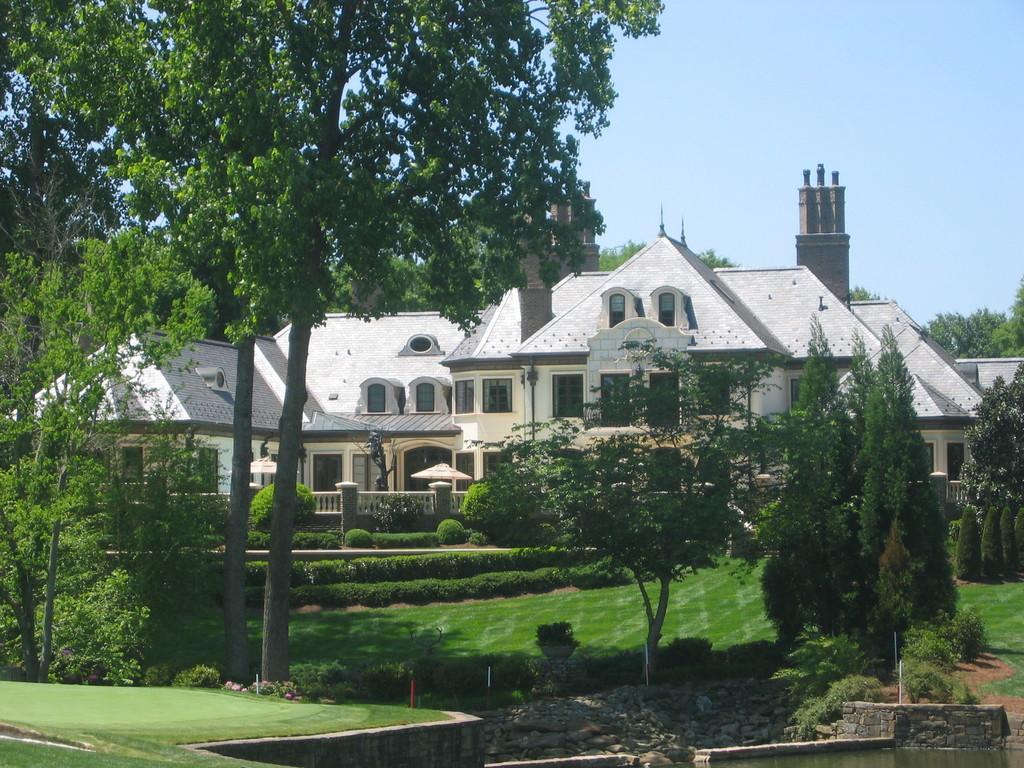In one or two sentences, can you explain what this image depicts? In the picture we can see a garden with a grass surface on it, we can see some plants. Trees and behind it, we can see a building with windows and glasses to it and behind it also we can see some trees and sky. 